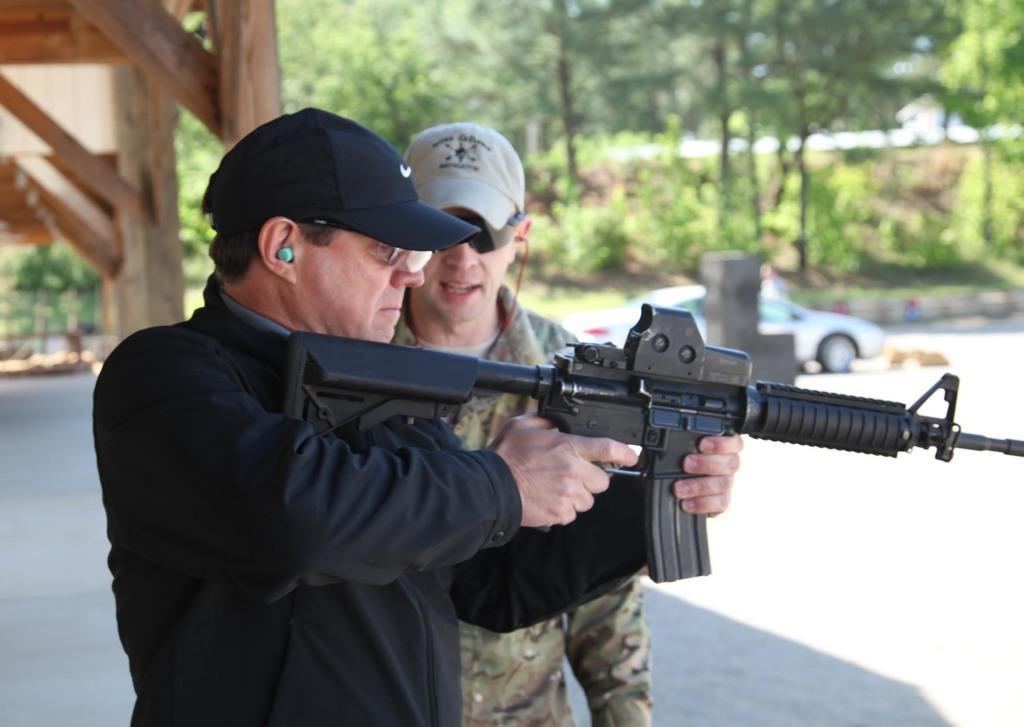How would you summarize this image in a sentence or two? In this image I see 2 men in which this man is wearing army uniform and this man is wearing black color dress and I see that both of them are wearing caps and I see that this man is holding a gun in his hand and I see the path. In the background I see a car over here and I see number of trees and I see the wooden things over here. 